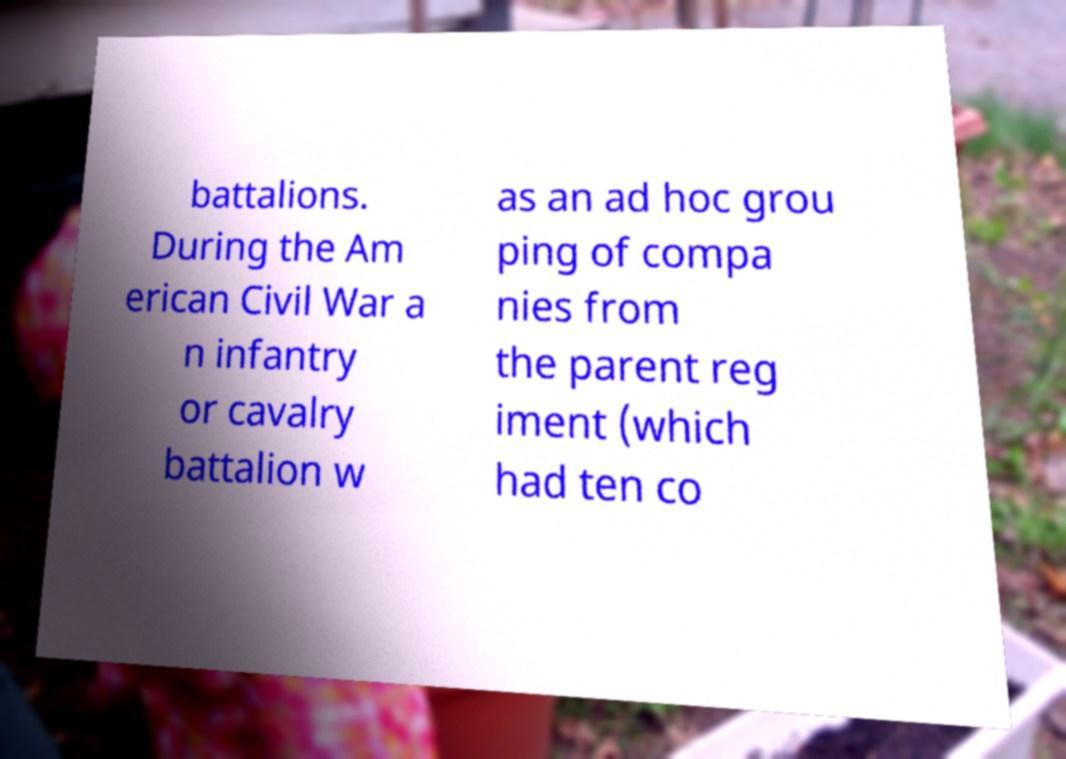Could you assist in decoding the text presented in this image and type it out clearly? battalions. During the Am erican Civil War a n infantry or cavalry battalion w as an ad hoc grou ping of compa nies from the parent reg iment (which had ten co 